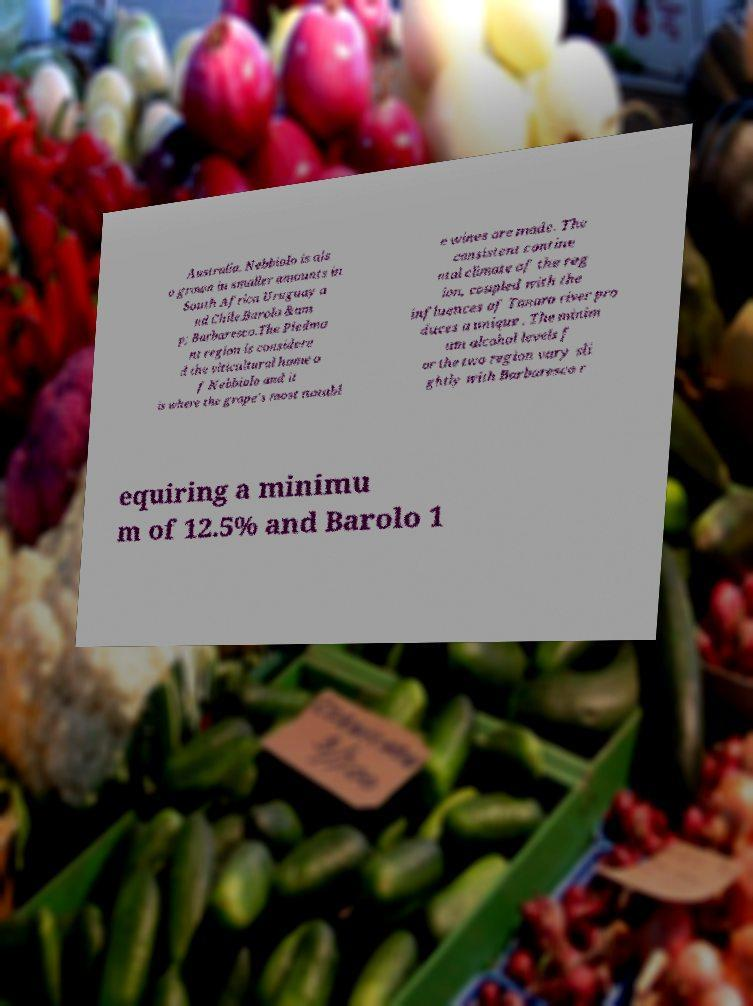Could you assist in decoding the text presented in this image and type it out clearly? Australia. Nebbiolo is als o grown in smaller amounts in South Africa Uruguay a nd Chile.Barolo &am p; Barbaresco.The Piedmo nt region is considere d the viticultural home o f Nebbiolo and it is where the grape's most notabl e wines are made. The consistent contine ntal climate of the reg ion, coupled with the influences of Tanaro river pro duces a unique . The minim um alcohol levels f or the two region vary sli ghtly with Barbaresco r equiring a minimu m of 12.5% and Barolo 1 